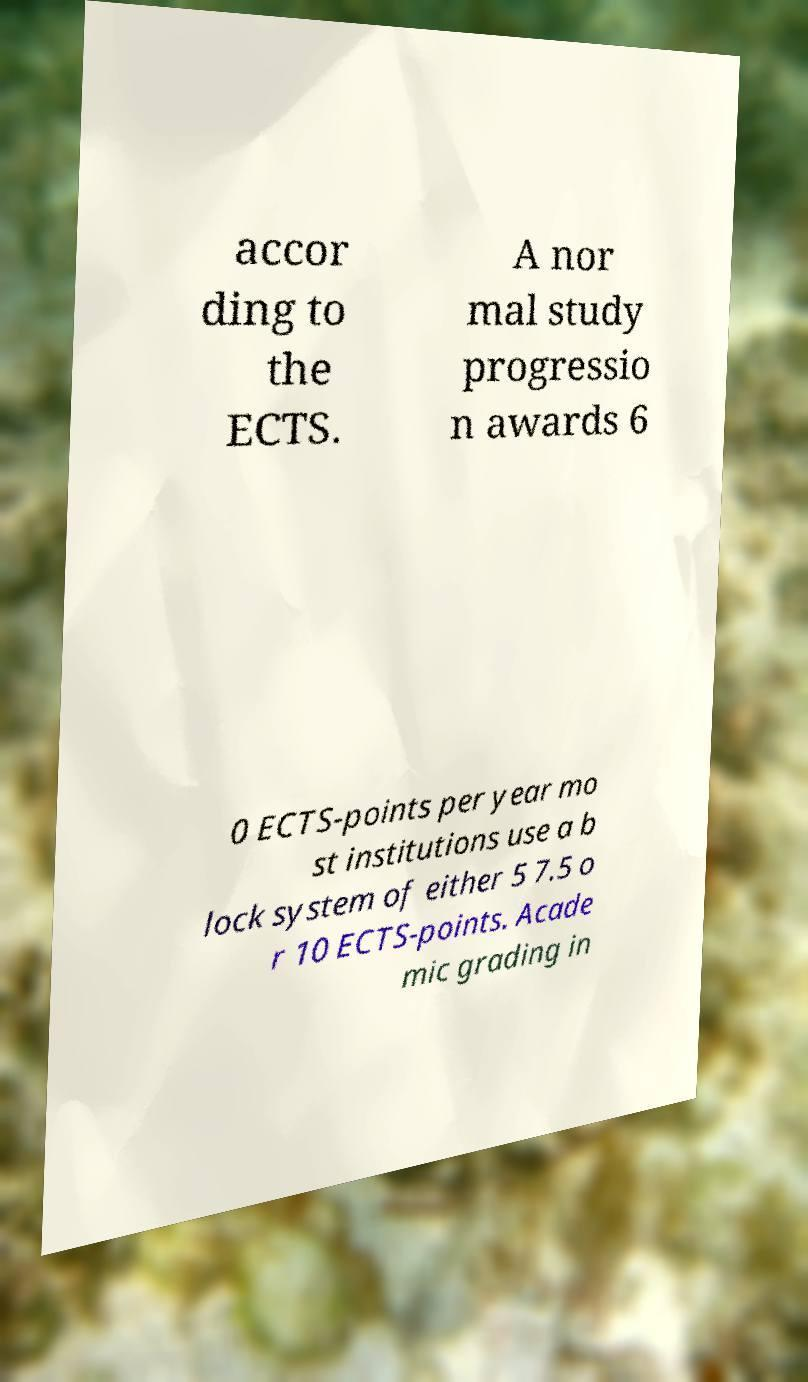There's text embedded in this image that I need extracted. Can you transcribe it verbatim? accor ding to the ECTS. A nor mal study progressio n awards 6 0 ECTS-points per year mo st institutions use a b lock system of either 5 7.5 o r 10 ECTS-points. Acade mic grading in 